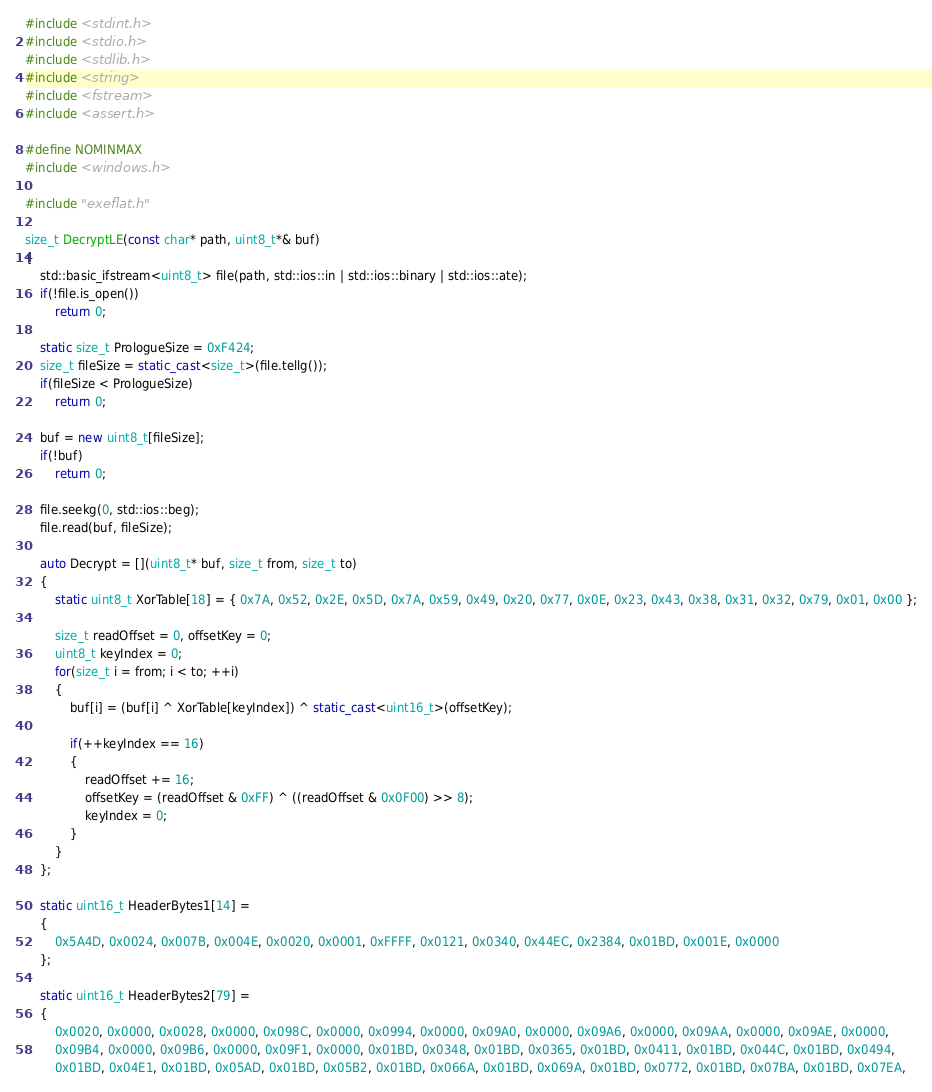<code> <loc_0><loc_0><loc_500><loc_500><_C++_>#include <stdint.h>
#include <stdio.h>
#include <stdlib.h>
#include <string>
#include <fstream>
#include <assert.h>

#define NOMINMAX
#include <windows.h>

#include "exeflat.h"

size_t DecryptLE(const char* path, uint8_t*& buf)
{
	std::basic_ifstream<uint8_t> file(path, std::ios::in | std::ios::binary | std::ios::ate);
	if(!file.is_open())
		return 0;

	static size_t PrologueSize = 0xF424;
	size_t fileSize = static_cast<size_t>(file.tellg());
	if(fileSize < PrologueSize)
		return 0;

	buf = new uint8_t[fileSize];
	if(!buf)
		return 0;

	file.seekg(0, std::ios::beg);
	file.read(buf, fileSize);

	auto Decrypt = [](uint8_t* buf, size_t from, size_t to)
	{
		static uint8_t XorTable[18] = { 0x7A, 0x52, 0x2E, 0x5D, 0x7A, 0x59, 0x49, 0x20, 0x77, 0x0E, 0x23, 0x43, 0x38, 0x31, 0x32, 0x79, 0x01, 0x00 };

		size_t readOffset = 0, offsetKey = 0;
		uint8_t keyIndex = 0;
		for(size_t i = from; i < to; ++i)
		{
			buf[i] = (buf[i] ^ XorTable[keyIndex]) ^ static_cast<uint16_t>(offsetKey);

			if(++keyIndex == 16)
			{
				readOffset += 16;
				offsetKey = (readOffset & 0xFF) ^ ((readOffset & 0x0F00) >> 8);
				keyIndex = 0;
			}
		}
	};

	static uint16_t HeaderBytes1[14] =
	{
		0x5A4D, 0x0024, 0x007B, 0x004E, 0x0020, 0x0001, 0xFFFF, 0x0121, 0x0340, 0x44EC, 0x2384, 0x01BD, 0x001E, 0x0000
	};

	static uint16_t HeaderBytes2[79] =
	{
		0x0020, 0x0000, 0x0028, 0x0000, 0x098C, 0x0000, 0x0994, 0x0000, 0x09A0, 0x0000, 0x09A6, 0x0000, 0x09AA, 0x0000, 0x09AE, 0x0000,
		0x09B4, 0x0000, 0x09B6, 0x0000, 0x09F1, 0x0000, 0x01BD, 0x0348, 0x01BD, 0x0365, 0x01BD, 0x0411, 0x01BD, 0x044C, 0x01BD, 0x0494,
		0x01BD, 0x04E1, 0x01BD, 0x05AD, 0x01BD, 0x05B2, 0x01BD, 0x066A, 0x01BD, 0x069A, 0x01BD, 0x0772, 0x01BD, 0x07BA, 0x01BD, 0x07EA,</code> 